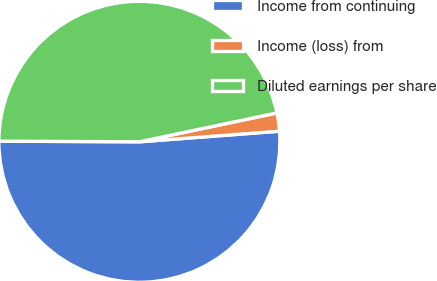Convert chart. <chart><loc_0><loc_0><loc_500><loc_500><pie_chart><fcel>Income from continuing<fcel>Income (loss) from<fcel>Diluted earnings per share<nl><fcel>51.28%<fcel>2.09%<fcel>46.64%<nl></chart> 